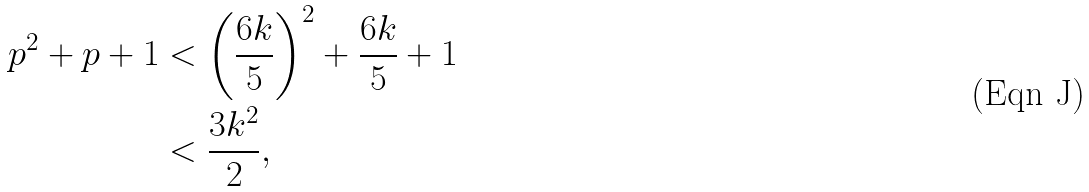Convert formula to latex. <formula><loc_0><loc_0><loc_500><loc_500>p ^ { 2 } + p + 1 & < \left ( \frac { 6 k } { 5 } \right ) ^ { 2 } + \frac { 6 k } { 5 } + 1 \\ & < \frac { 3 k ^ { 2 } } { 2 } ,</formula> 